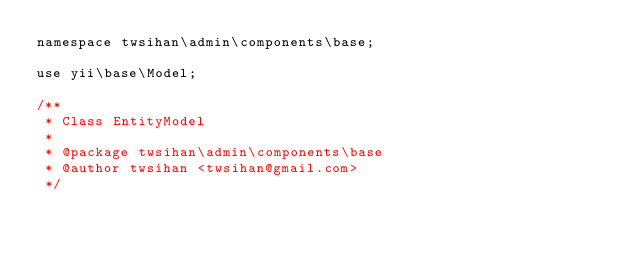Convert code to text. <code><loc_0><loc_0><loc_500><loc_500><_PHP_>namespace twsihan\admin\components\base;

use yii\base\Model;

/**
 * Class EntityModel
 *
 * @package twsihan\admin\components\base
 * @author twsihan <twsihan@gmail.com>
 */</code> 